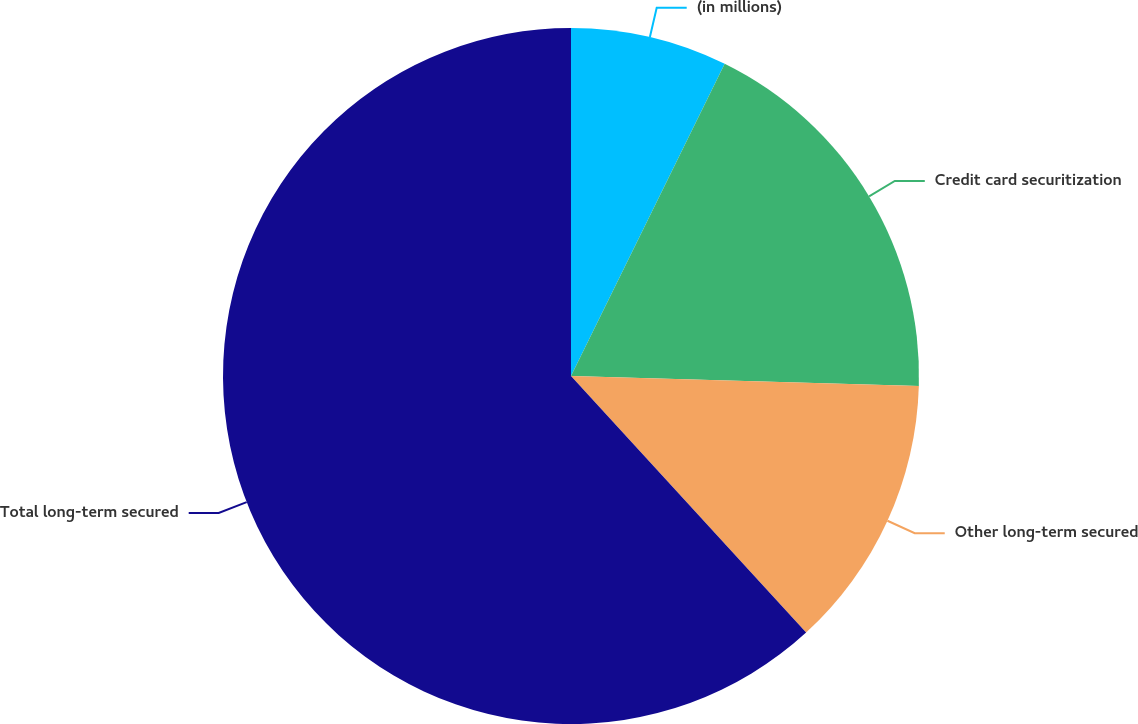Convert chart to OTSL. <chart><loc_0><loc_0><loc_500><loc_500><pie_chart><fcel>(in millions)<fcel>Credit card securitization<fcel>Other long-term secured<fcel>Total long-term secured<nl><fcel>7.28%<fcel>18.18%<fcel>12.73%<fcel>61.8%<nl></chart> 